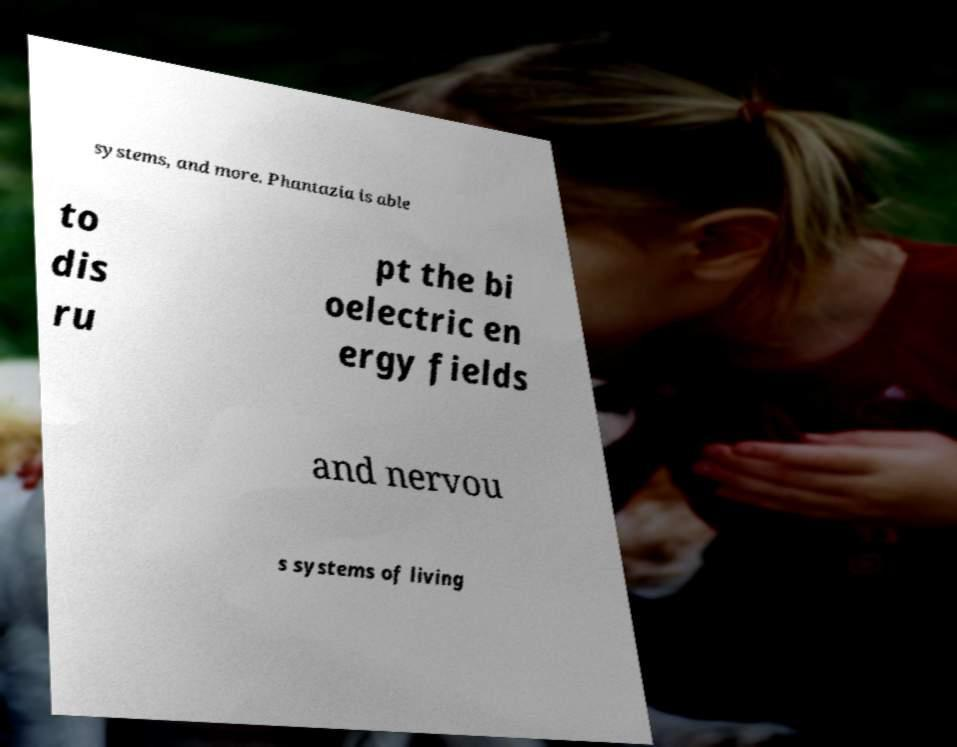Please identify and transcribe the text found in this image. systems, and more. Phantazia is able to dis ru pt the bi oelectric en ergy fields and nervou s systems of living 